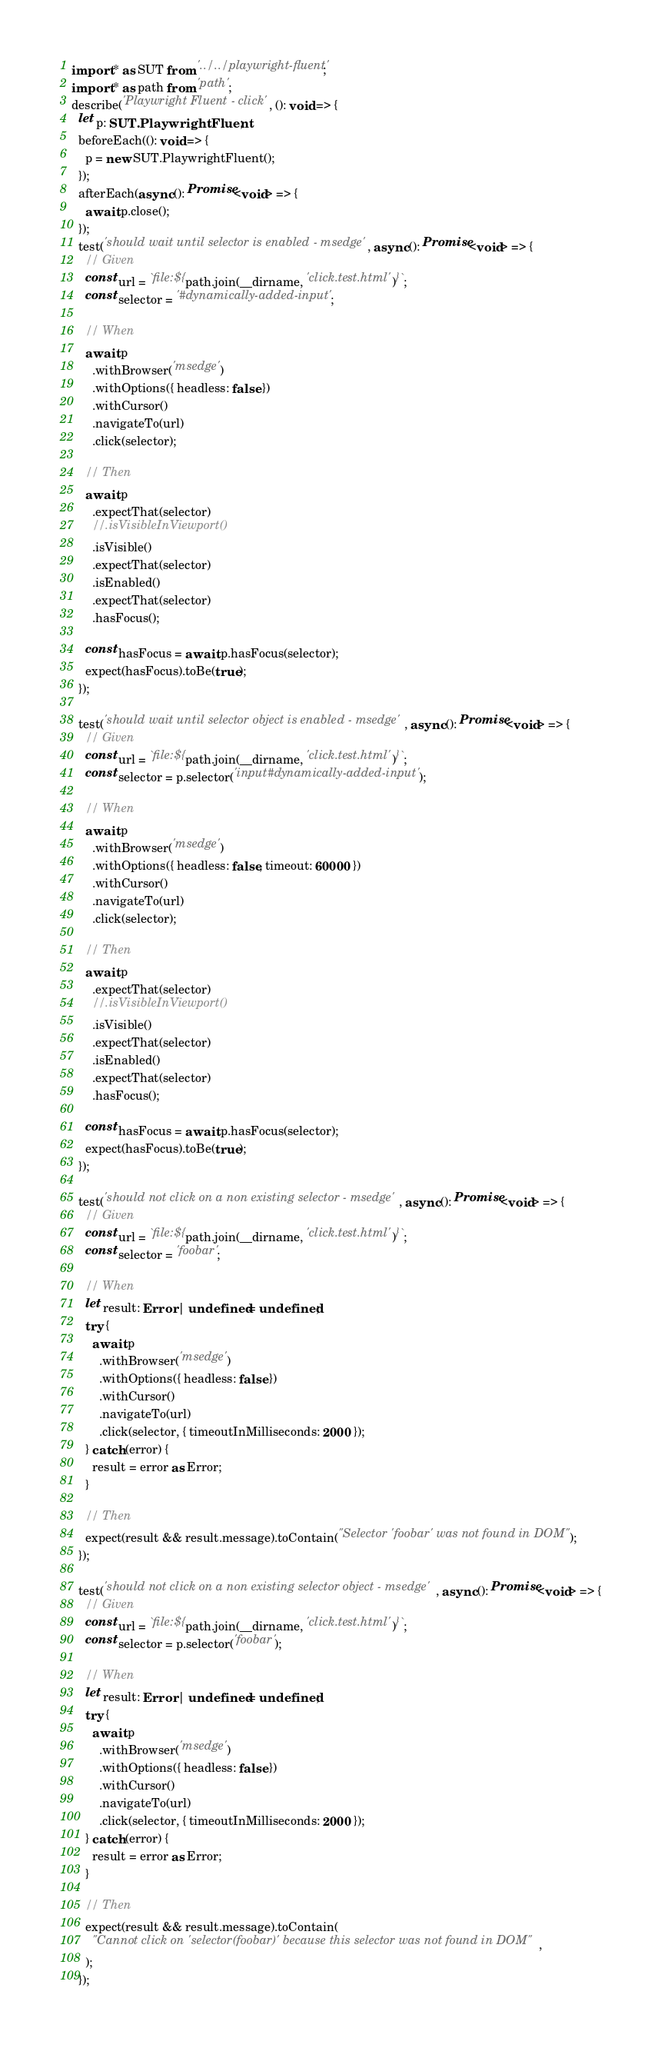Convert code to text. <code><loc_0><loc_0><loc_500><loc_500><_TypeScript_>import * as SUT from '../../playwright-fluent';
import * as path from 'path';
describe('Playwright Fluent - click', (): void => {
  let p: SUT.PlaywrightFluent;
  beforeEach((): void => {
    p = new SUT.PlaywrightFluent();
  });
  afterEach(async (): Promise<void> => {
    await p.close();
  });
  test('should wait until selector is enabled - msedge', async (): Promise<void> => {
    // Given
    const url = `file:${path.join(__dirname, 'click.test.html')}`;
    const selector = '#dynamically-added-input';

    // When
    await p
      .withBrowser('msedge')
      .withOptions({ headless: false })
      .withCursor()
      .navigateTo(url)
      .click(selector);

    // Then
    await p
      .expectThat(selector)
      //.isVisibleInViewport()
      .isVisible()
      .expectThat(selector)
      .isEnabled()
      .expectThat(selector)
      .hasFocus();

    const hasFocus = await p.hasFocus(selector);
    expect(hasFocus).toBe(true);
  });

  test('should wait until selector object is enabled - msedge', async (): Promise<void> => {
    // Given
    const url = `file:${path.join(__dirname, 'click.test.html')}`;
    const selector = p.selector('input#dynamically-added-input');

    // When
    await p
      .withBrowser('msedge')
      .withOptions({ headless: false, timeout: 60000 })
      .withCursor()
      .navigateTo(url)
      .click(selector);

    // Then
    await p
      .expectThat(selector)
      //.isVisibleInViewport()
      .isVisible()
      .expectThat(selector)
      .isEnabled()
      .expectThat(selector)
      .hasFocus();

    const hasFocus = await p.hasFocus(selector);
    expect(hasFocus).toBe(true);
  });

  test('should not click on a non existing selector - msedge', async (): Promise<void> => {
    // Given
    const url = `file:${path.join(__dirname, 'click.test.html')}`;
    const selector = 'foobar';

    // When
    let result: Error | undefined = undefined;
    try {
      await p
        .withBrowser('msedge')
        .withOptions({ headless: false })
        .withCursor()
        .navigateTo(url)
        .click(selector, { timeoutInMilliseconds: 2000 });
    } catch (error) {
      result = error as Error;
    }

    // Then
    expect(result && result.message).toContain("Selector 'foobar' was not found in DOM");
  });

  test('should not click on a non existing selector object - msedge', async (): Promise<void> => {
    // Given
    const url = `file:${path.join(__dirname, 'click.test.html')}`;
    const selector = p.selector('foobar');

    // When
    let result: Error | undefined = undefined;
    try {
      await p
        .withBrowser('msedge')
        .withOptions({ headless: false })
        .withCursor()
        .navigateTo(url)
        .click(selector, { timeoutInMilliseconds: 2000 });
    } catch (error) {
      result = error as Error;
    }

    // Then
    expect(result && result.message).toContain(
      "Cannot click on 'selector(foobar)' because this selector was not found in DOM",
    );
  });</code> 